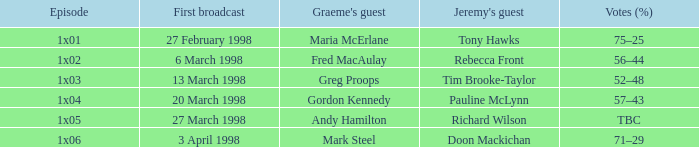Would you be able to parse every entry in this table? {'header': ['Episode', 'First broadcast', "Graeme's guest", "Jeremy's guest", 'Votes (%)'], 'rows': [['1x01', '27 February 1998', 'Maria McErlane', 'Tony Hawks', '75–25'], ['1x02', '6 March 1998', 'Fred MacAulay', 'Rebecca Front', '56–44'], ['1x03', '13 March 1998', 'Greg Proops', 'Tim Brooke-Taylor', '52–48'], ['1x04', '20 March 1998', 'Gordon Kennedy', 'Pauline McLynn', '57–43'], ['1x05', '27 March 1998', 'Andy Hamilton', 'Richard Wilson', 'TBC'], ['1x06', '3 April 1998', 'Mark Steel', 'Doon Mackichan', '71–29']]} What is Jeremy's Guest, when First Broadcast is "20 March 1998"? Pauline McLynn. 